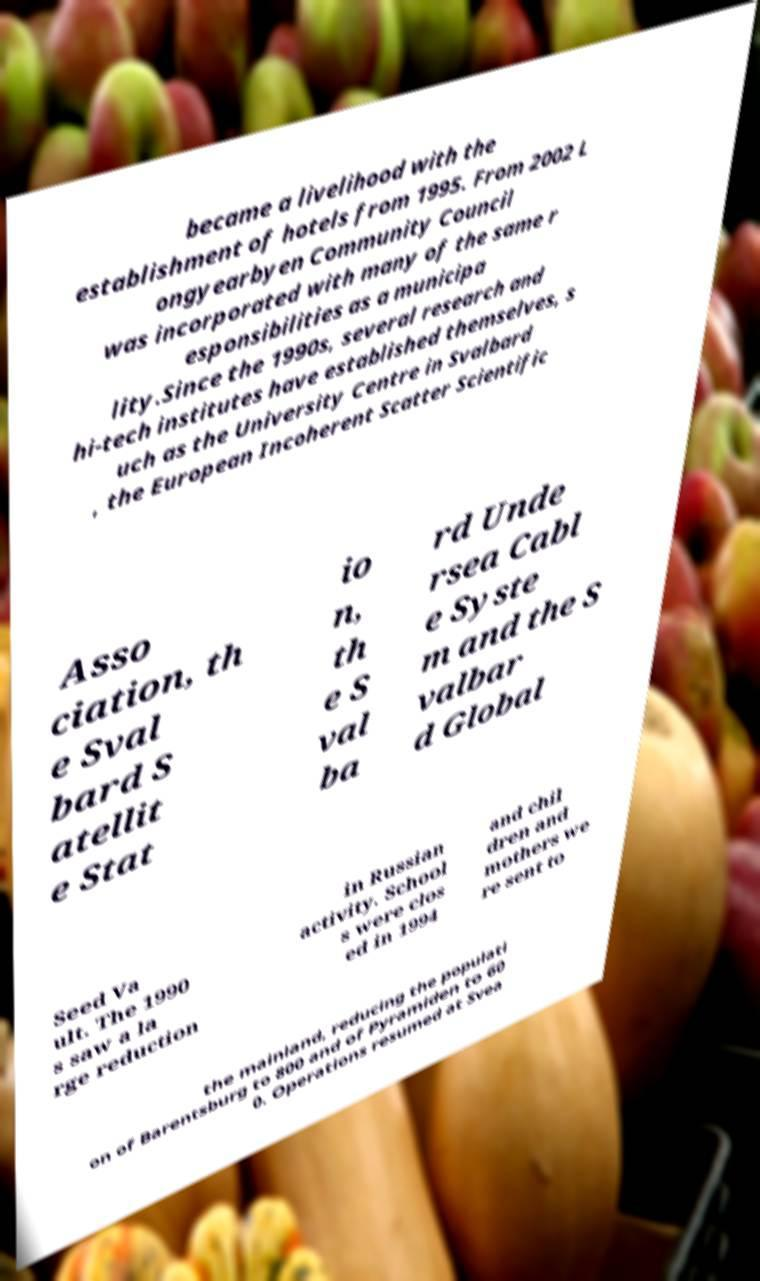Could you assist in decoding the text presented in this image and type it out clearly? became a livelihood with the establishment of hotels from 1995. From 2002 L ongyearbyen Community Council was incorporated with many of the same r esponsibilities as a municipa lity.Since the 1990s, several research and hi-tech institutes have established themselves, s uch as the University Centre in Svalbard , the European Incoherent Scatter Scientific Asso ciation, th e Sval bard S atellit e Stat io n, th e S val ba rd Unde rsea Cabl e Syste m and the S valbar d Global Seed Va ult. The 1990 s saw a la rge reduction in Russian activity. School s were clos ed in 1994 and chil dren and mothers we re sent to the mainland, reducing the populati on of Barentsburg to 800 and of Pyramiden to 60 0. Operations resumed at Svea 